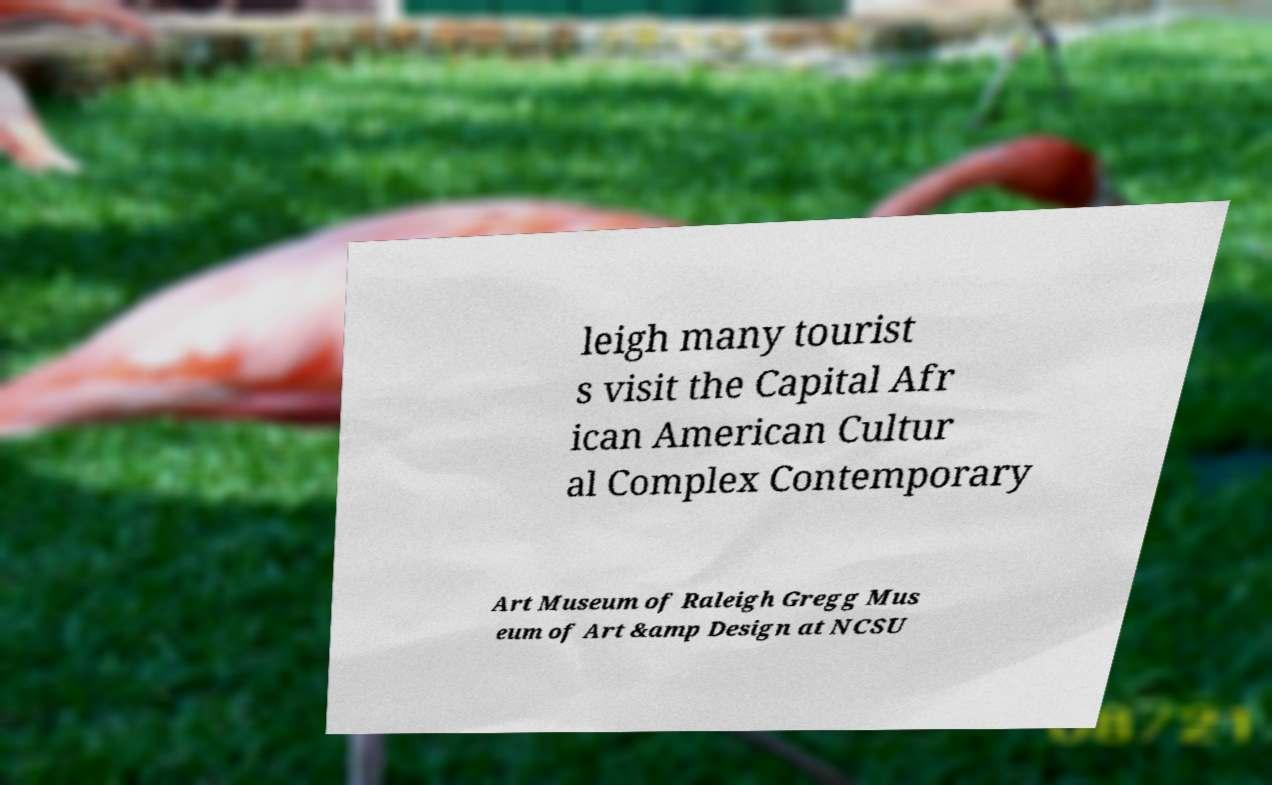Can you accurately transcribe the text from the provided image for me? leigh many tourist s visit the Capital Afr ican American Cultur al Complex Contemporary Art Museum of Raleigh Gregg Mus eum of Art &amp Design at NCSU 